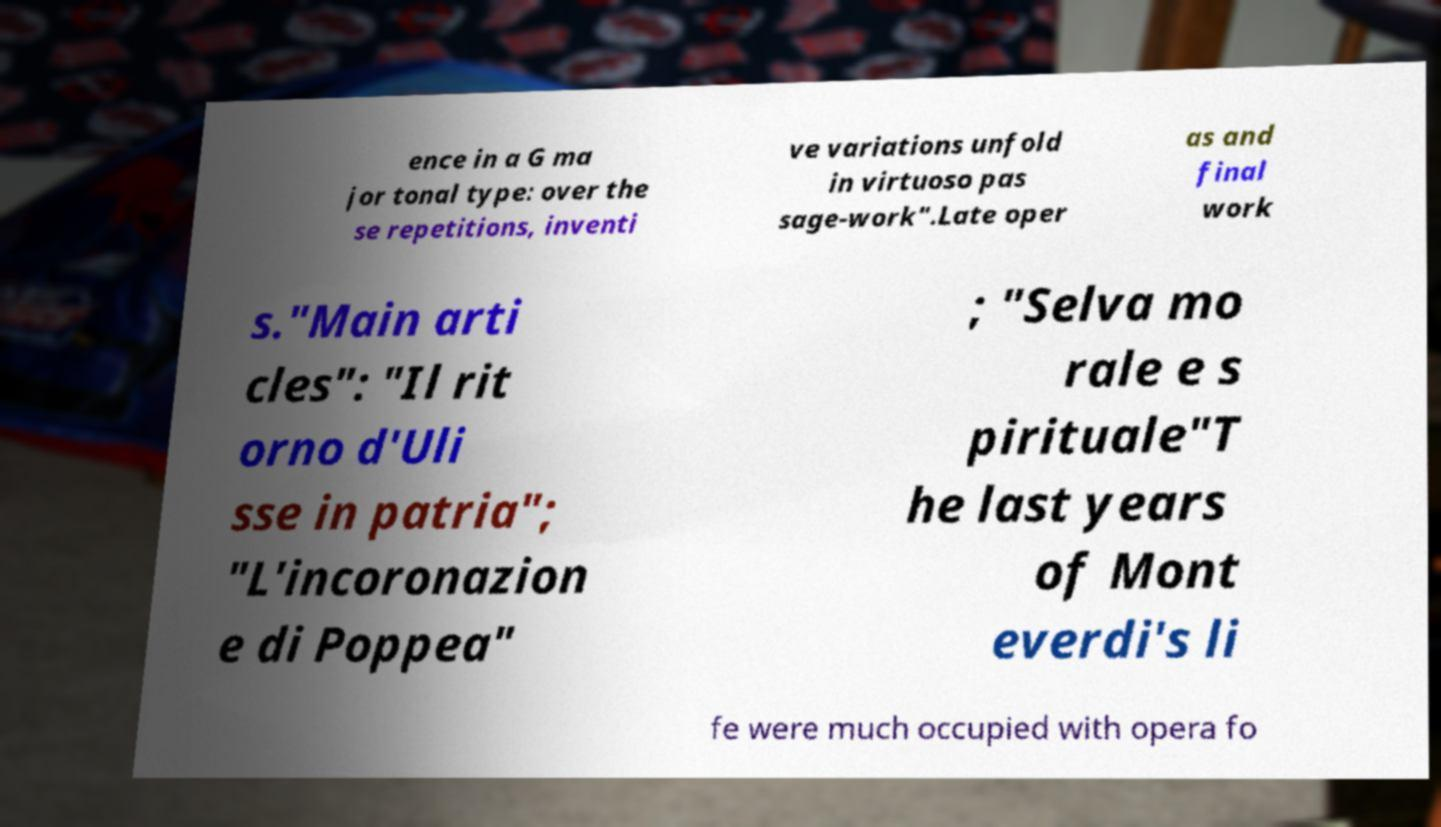For documentation purposes, I need the text within this image transcribed. Could you provide that? ence in a G ma jor tonal type: over the se repetitions, inventi ve variations unfold in virtuoso pas sage-work".Late oper as and final work s."Main arti cles": "Il rit orno d'Uli sse in patria"; "L'incoronazion e di Poppea" ; "Selva mo rale e s pirituale"T he last years of Mont everdi's li fe were much occupied with opera fo 